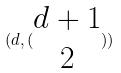<formula> <loc_0><loc_0><loc_500><loc_500>( d , ( \begin{matrix} d + 1 \\ 2 \end{matrix} ) )</formula> 